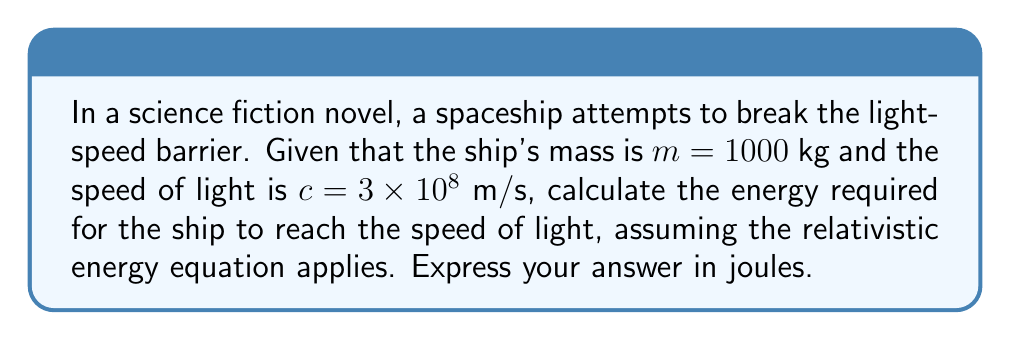Can you solve this math problem? To solve this problem, we'll use the relativistic energy equation:

$$E = \gamma mc^2$$

Where:
$E$ is the total energy
$m$ is the rest mass of the object
$c$ is the speed of light
$\gamma$ is the Lorentz factor, given by:

$$\gamma = \frac{1}{\sqrt{1 - \frac{v^2}{c^2}}}$$

Where $v$ is the velocity of the object.

Step 1: As the ship approaches the speed of light, $v$ approaches $c$, so $\frac{v^2}{c^2}$ approaches 1.

Step 2: When $\frac{v^2}{c^2} = 1$, the denominator of the Lorentz factor becomes zero, making $\gamma$ approach infinity.

Step 3: Therefore, the energy required to reach the speed of light becomes:

$$E = \lim_{v \to c} \frac{mc^2}{\sqrt{1 - \frac{v^2}{c^2}}} = \infty$$

Step 4: Substitute the given values:
$m = 1000$ kg
$c = 3 \times 10^8$ m/s

$$E = \infty \times 1000 \times (3 \times 10^8)^2 = \infty$$

The energy required is infinite, which is why it's theoretically impossible for objects with mass to reach the speed of light.
Answer: $\infty$ joules 